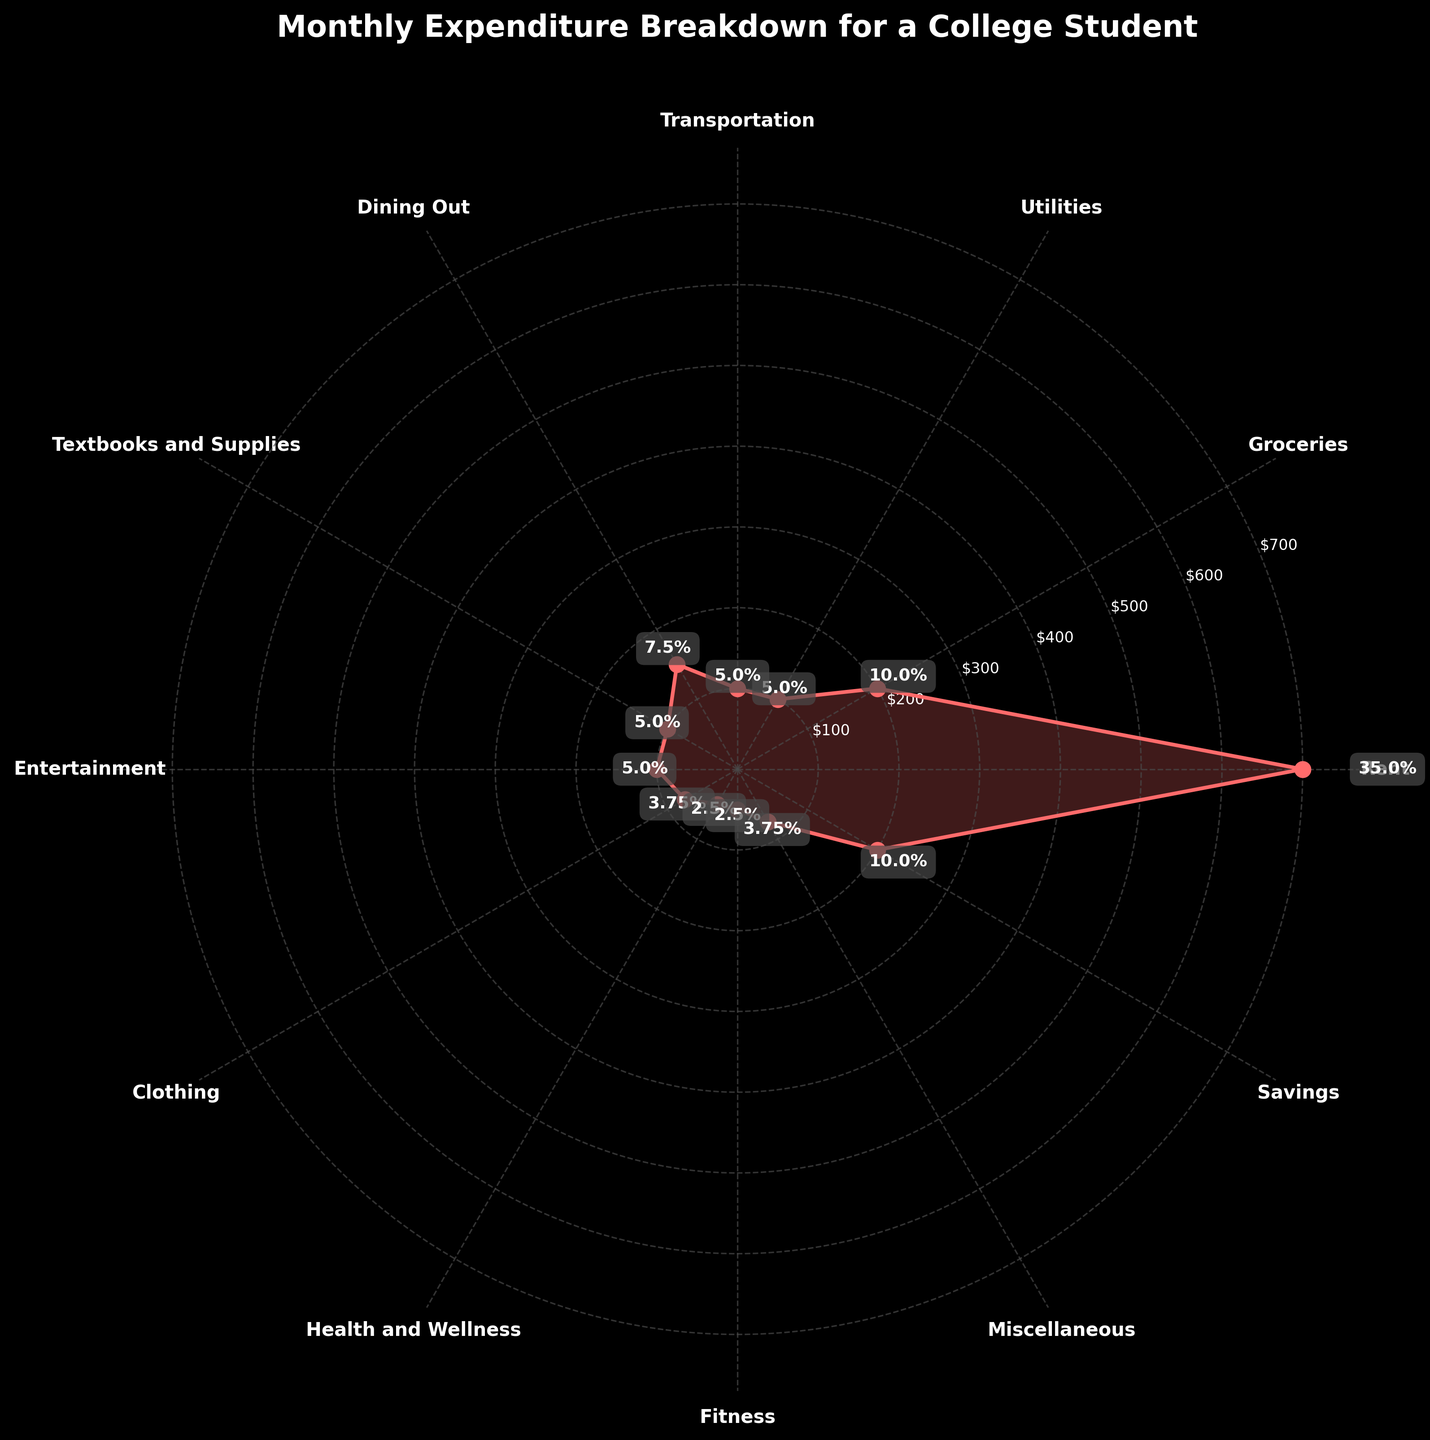What is the title of the plot? The title is located at the top of the plot, conveying the main subject of the visualized data. It reads "Monthly Expenditure Breakdown for a College Student".
Answer: Monthly Expenditure Breakdown for a College Student What is the largest expenditure category? The largest expenditure category can be identified by the radial length that extends the furthest from the center. In this case, it is the "Rent" category.
Answer: Rent How much does the student spend on Groceries and Dining Out combined? The amounts for Groceries and Dining Out are labeled as $200 and $150, respectively. Summing these amounts gives $200 + $150 = $350.
Answer: $350 Which category has the smallest expenditure? The category with the smallest expenditure can be identified by the shortest radial length or smallest numerical label. Both "Health and Wellness" and "Fitness" are the smallest with $50 each.
Answer: Health and Wellness and Fitness Which category has the highest percentage of the total expenditure? By looking at the percentage labels, the category with the highest percentage is "Rent" with 35%.
Answer: Rent What is the total percentage spent on Textbooks and Supplies, Entertainment, and Miscellaneous? The percentages for Textbooks and Supplies, Entertainment, and Miscellaneous are 5%, 5%, and 3.75% respectively. Summing these percentages gives 5 + 5 + 3.75 = 13.75%.
Answer: 13.75% How much more is spent on Rent compared to Transportation? The amounts for Rent and Transportation are $700 and $100 respectively. The difference is calculated as $700 - $100 = $600.
Answer: $600 What is the percentage range of all the expenditure categories? The percentage range is found by subtracting the smallest percentage from the largest percentage. The smallest percentage is 2.5% (Health and Wellness and Fitness), and the largest is 35% (Rent). The range is 35% - 2.5% = 32.5%.
Answer: 32.5% Which categories have the same expenditure amount of $100? By looking at the radial lengths and labels, the categories with $100 expenditure are Utilities, Transportation, Textbooks and Supplies, and Entertainment.
Answer: Utilities, Transportation, Textbooks and Supplies, Entertainment Is the expenditure on Savings greater than that on Clothing? The amount spent on Savings is $200, while on Clothing, it is $75. Since $200 is greater than $75, the expenditure on Savings is indeed greater than that on Clothing.
Answer: Yes 